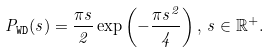<formula> <loc_0><loc_0><loc_500><loc_500>P _ { \tt W D } ( s ) = \frac { \pi s } { 2 } \exp \left ( - \frac { \pi s ^ { 2 } } { 4 } \right ) , \, s \in { \mathbb { R } } ^ { + } .</formula> 